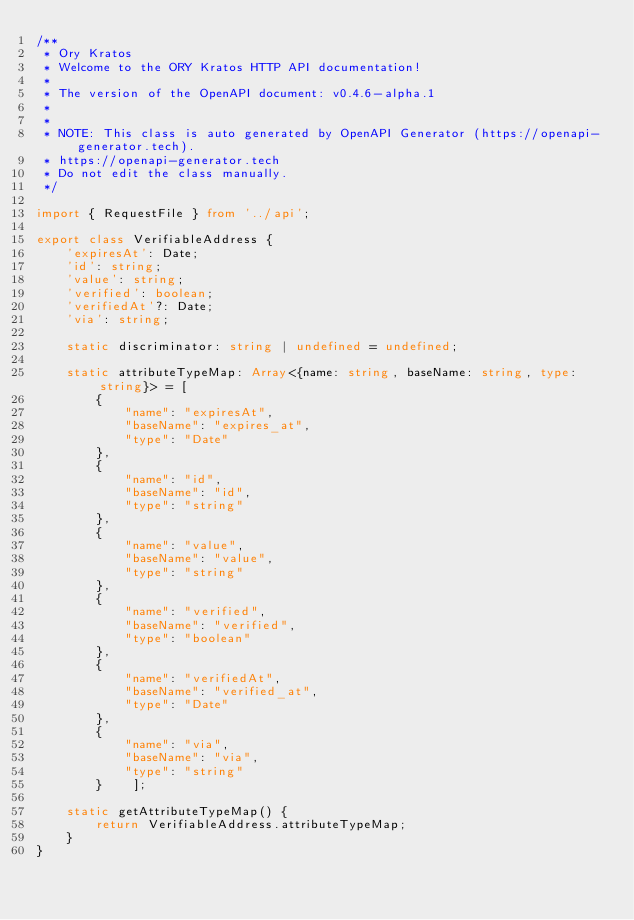<code> <loc_0><loc_0><loc_500><loc_500><_TypeScript_>/**
 * Ory Kratos
 * Welcome to the ORY Kratos HTTP API documentation!
 *
 * The version of the OpenAPI document: v0.4.6-alpha.1
 * 
 *
 * NOTE: This class is auto generated by OpenAPI Generator (https://openapi-generator.tech).
 * https://openapi-generator.tech
 * Do not edit the class manually.
 */

import { RequestFile } from '../api';

export class VerifiableAddress {
    'expiresAt': Date;
    'id': string;
    'value': string;
    'verified': boolean;
    'verifiedAt'?: Date;
    'via': string;

    static discriminator: string | undefined = undefined;

    static attributeTypeMap: Array<{name: string, baseName: string, type: string}> = [
        {
            "name": "expiresAt",
            "baseName": "expires_at",
            "type": "Date"
        },
        {
            "name": "id",
            "baseName": "id",
            "type": "string"
        },
        {
            "name": "value",
            "baseName": "value",
            "type": "string"
        },
        {
            "name": "verified",
            "baseName": "verified",
            "type": "boolean"
        },
        {
            "name": "verifiedAt",
            "baseName": "verified_at",
            "type": "Date"
        },
        {
            "name": "via",
            "baseName": "via",
            "type": "string"
        }    ];

    static getAttributeTypeMap() {
        return VerifiableAddress.attributeTypeMap;
    }
}

</code> 